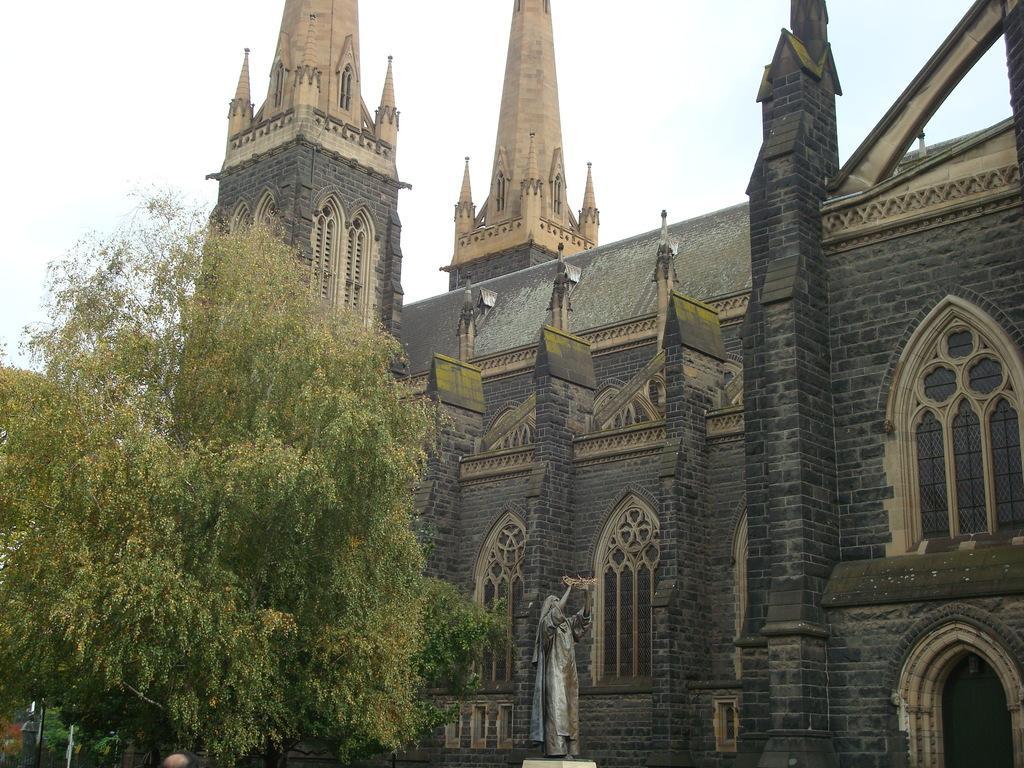Describe this image in one or two sentences. This picture might be taken from outside of the city. In this image, on the left side, we can see some trees. In the middle of the image, we can see a statue. On the right side, we can see a building, glass window. At the top, we can see a sky. 